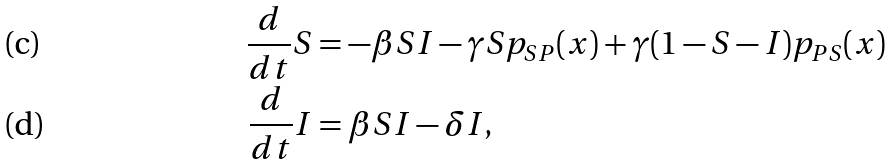Convert formula to latex. <formula><loc_0><loc_0><loc_500><loc_500>\frac { d } { d t } S & = - \beta S I - \gamma S p _ { S P } ( x ) + \gamma ( 1 - S - I ) p _ { P S } ( x ) \\ \frac { d } { d t } I & = \beta S I - \delta I ,</formula> 